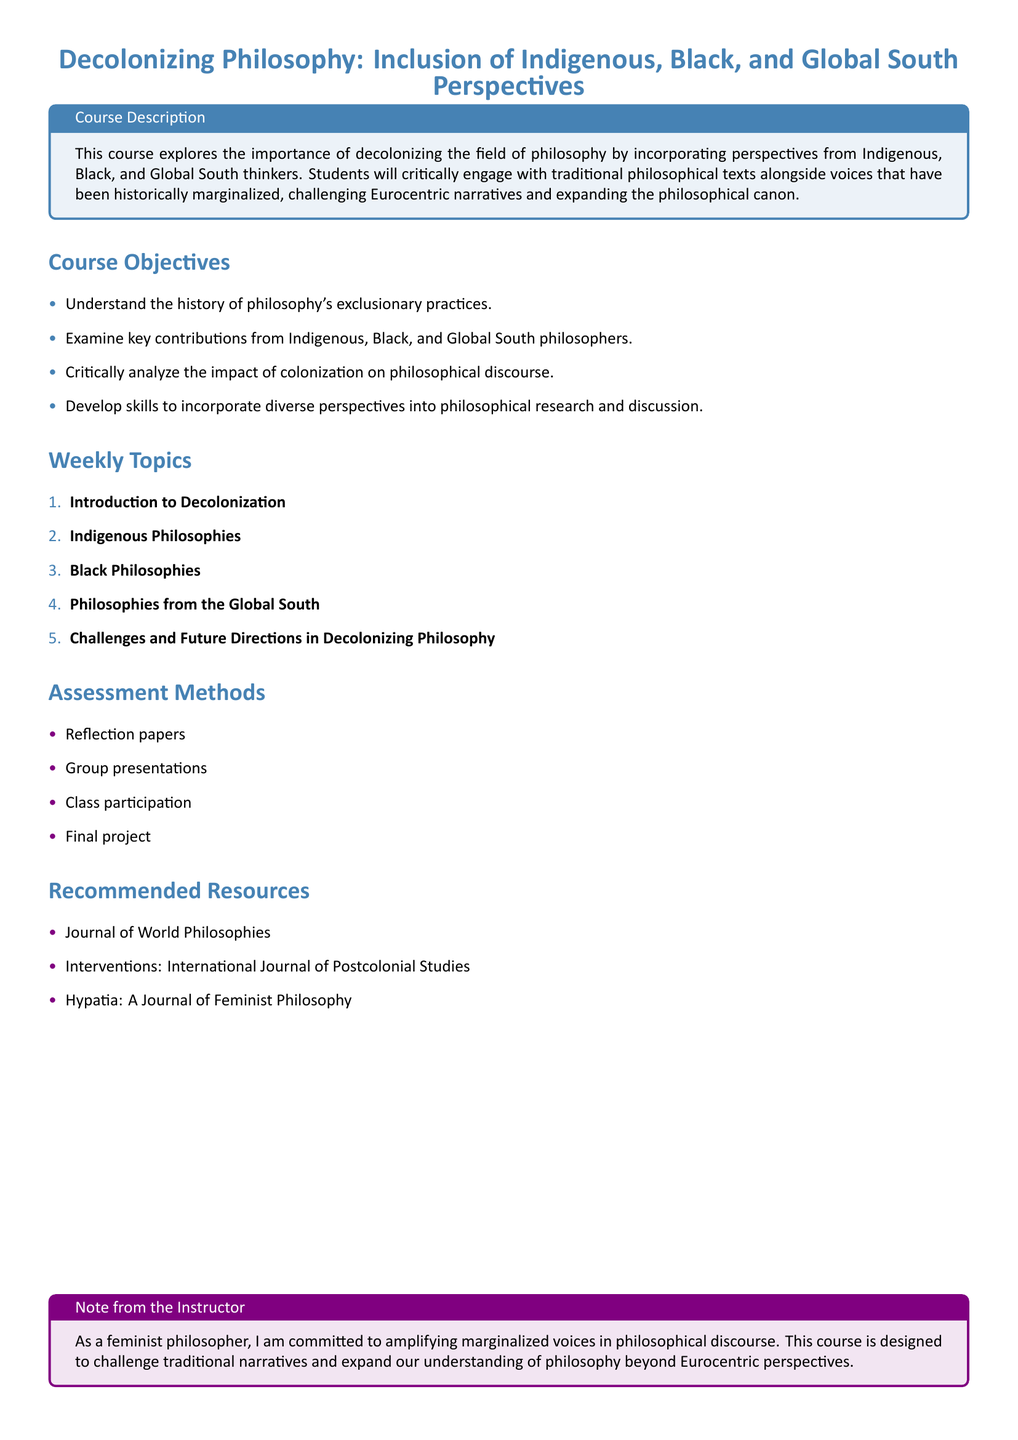What is the course title? The title of the course is stated at the beginning of the document, highlighting its focus on decolonization and inclusion.
Answer: Decolonizing Philosophy: Inclusion of Indigenous, Black, and Global South Perspectives What is a key focus of this course? The document mentions that the course aims to include perspectives from historically marginalized voices in philosophy.
Answer: Incorporating perspectives from Indigenous, Black, and Global South thinkers How many weekly topics are listed? The weekly topics section enumerates each topic, allowing for easy counting.
Answer: 5 Name one assessment method mentioned in the syllabus. The document specifies various forms of assessment that students will engage in throughout the course.
Answer: Reflection papers What does the instructor emphasize in the note? The instructor's note indicates their commitment to a specific philosophical agenda regarding representation.
Answer: Amplifying marginalized voices in philosophical discourse What is one of the recommended resources? The syllabus provides a list of journals that are pertinent to the course content.
Answer: Journal of World Philosophies What is the first weekly topic? The first weekly topic is clearly stated as part of the structured list of topics in the document.
Answer: Introduction to Decolonization What is one objective of the course? The objectives section outlines specific goals for students, highlighting their learning outcomes.
Answer: Understand the history of philosophy's exclusionary practices What color is used in the course description box? The course description box is colored, which can be identified from the document's styling.
Answer: Custom blue 